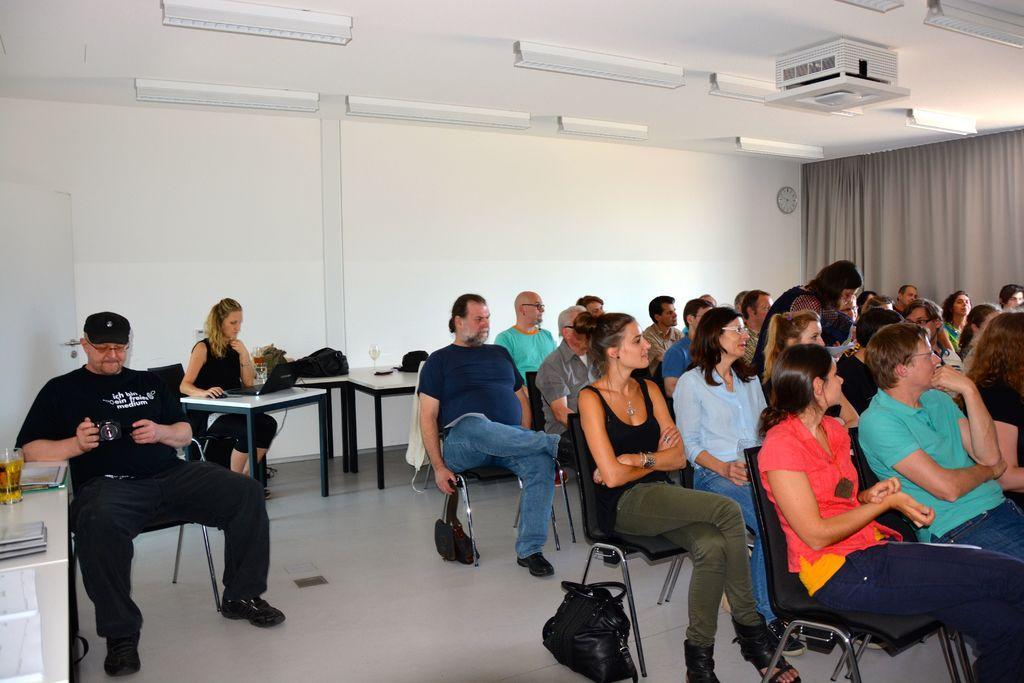Could you give a brief overview of what you see in this image? In this image we can see some people sitting in a room, a woman is working on the laptop and a man holding a camera there are a few tables and objects on the table. In the background there is a wall and a clock attached to the wall and there are some lights attached to the roof. 